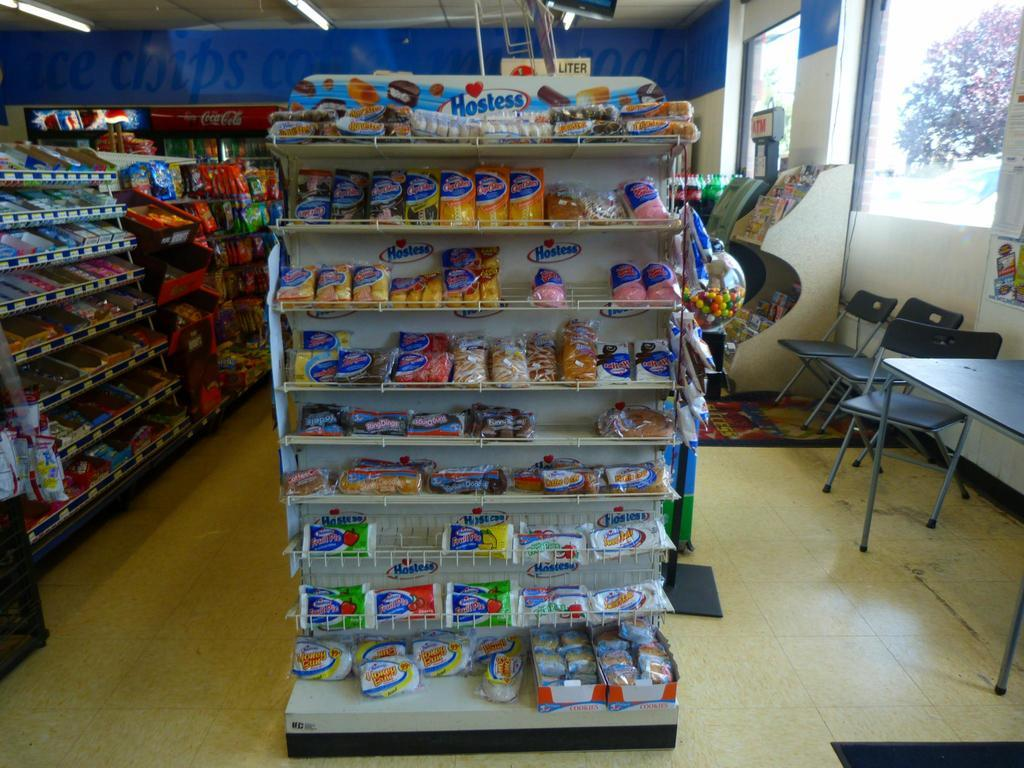<image>
Share a concise interpretation of the image provided. Bunch of Hostess products on a store shelf. 